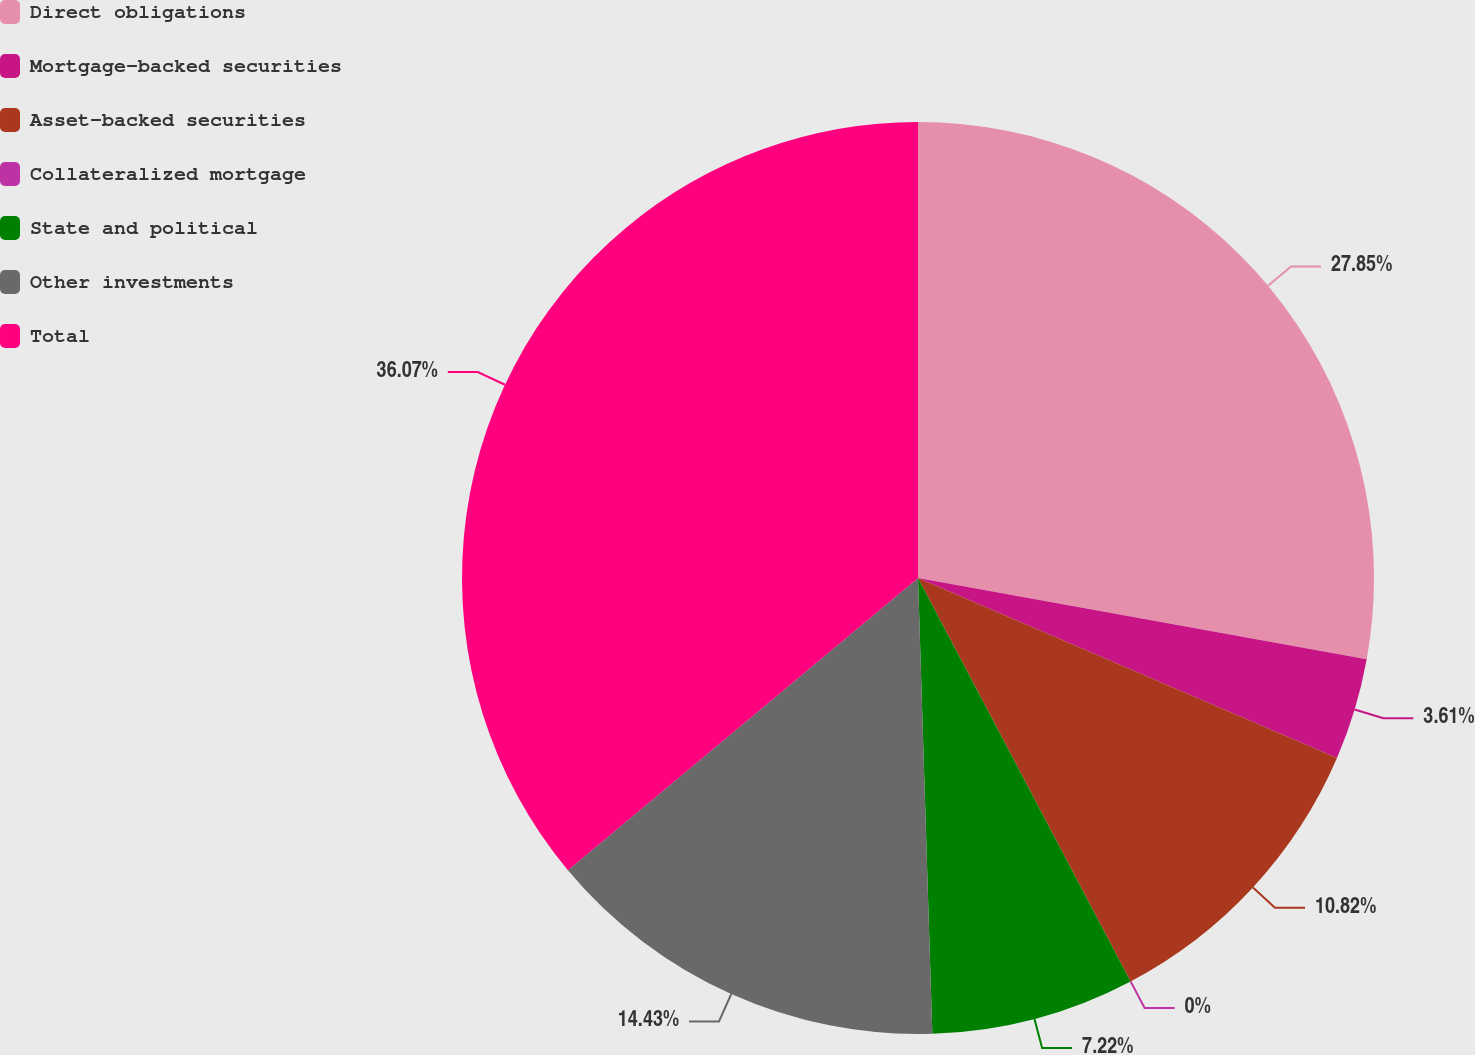Convert chart to OTSL. <chart><loc_0><loc_0><loc_500><loc_500><pie_chart><fcel>Direct obligations<fcel>Mortgage-backed securities<fcel>Asset-backed securities<fcel>Collateralized mortgage<fcel>State and political<fcel>Other investments<fcel>Total<nl><fcel>27.85%<fcel>3.61%<fcel>10.82%<fcel>0.0%<fcel>7.22%<fcel>14.43%<fcel>36.07%<nl></chart> 